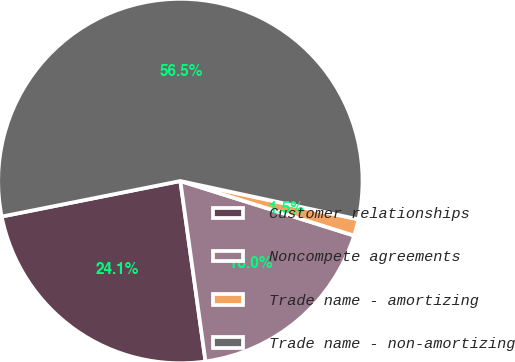Convert chart. <chart><loc_0><loc_0><loc_500><loc_500><pie_chart><fcel>Customer relationships<fcel>Noncompete agreements<fcel>Trade name - amortizing<fcel>Trade name - non-amortizing<nl><fcel>24.08%<fcel>17.95%<fcel>1.47%<fcel>56.5%<nl></chart> 